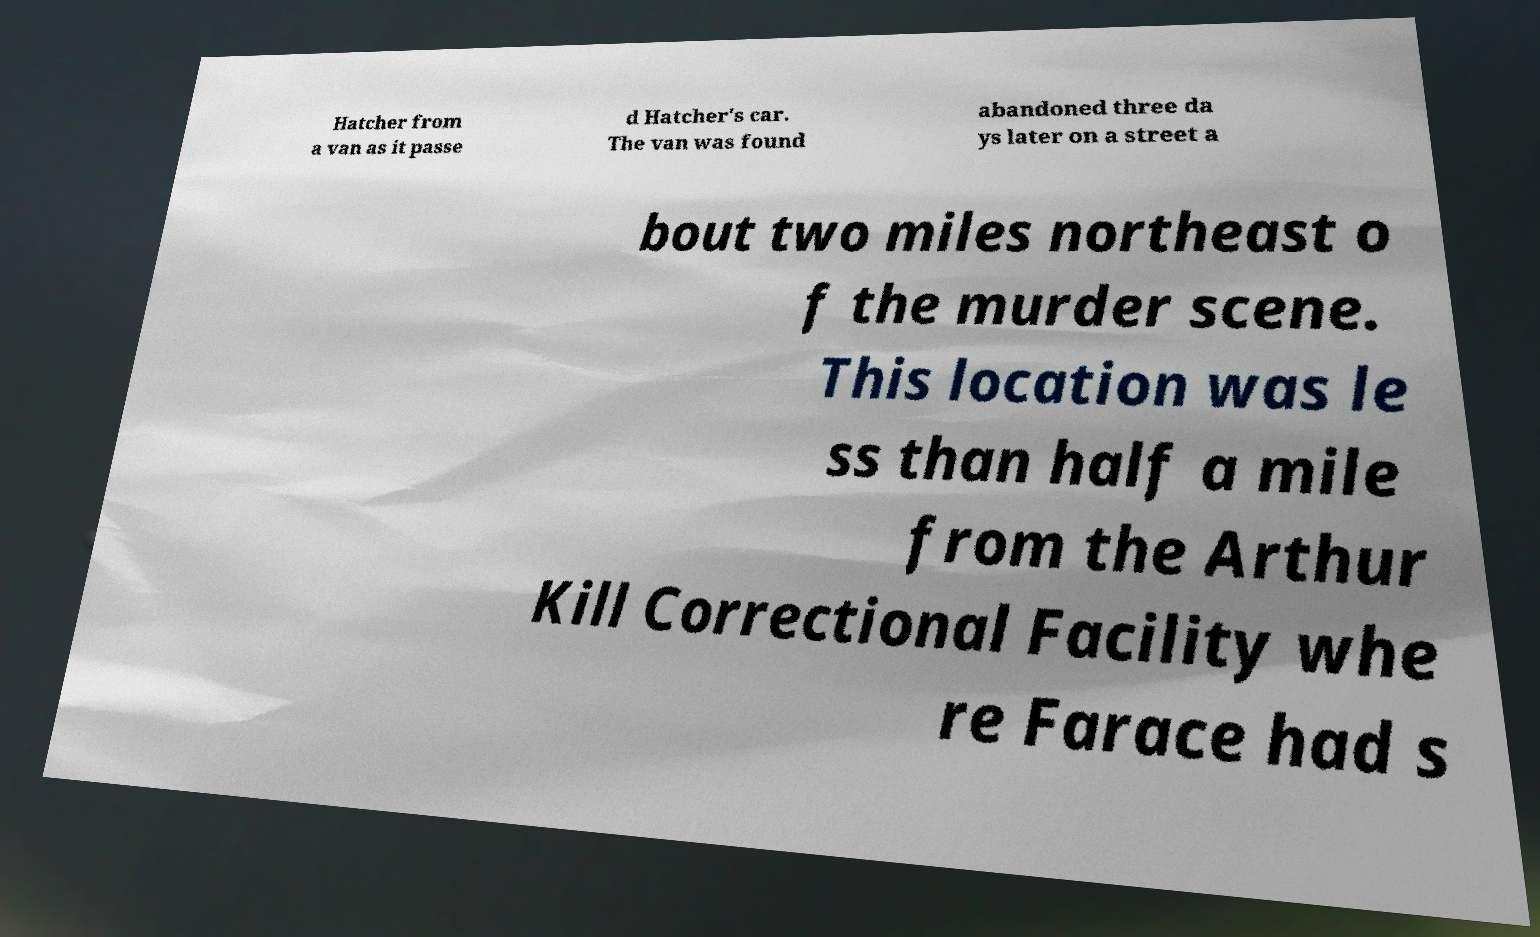Please read and relay the text visible in this image. What does it say? Hatcher from a van as it passe d Hatcher's car. The van was found abandoned three da ys later on a street a bout two miles northeast o f the murder scene. This location was le ss than half a mile from the Arthur Kill Correctional Facility whe re Farace had s 